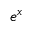<formula> <loc_0><loc_0><loc_500><loc_500>e ^ { x }</formula> 